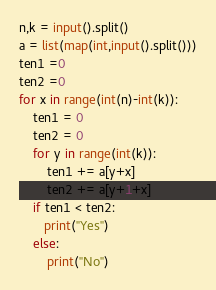Convert code to text. <code><loc_0><loc_0><loc_500><loc_500><_Python_>n,k = input().split()
a = list(map(int,input().split()))
ten1 =0
ten2 =0
for x in range(int(n)-int(k)):
    ten1 = 0
    ten2 = 0
    for y in range(int(k)):
        ten1 += a[y+x]
        ten2 += a[y+1+x]
    if ten1 < ten2:
       print("Yes")
    else:
        print("No")</code> 